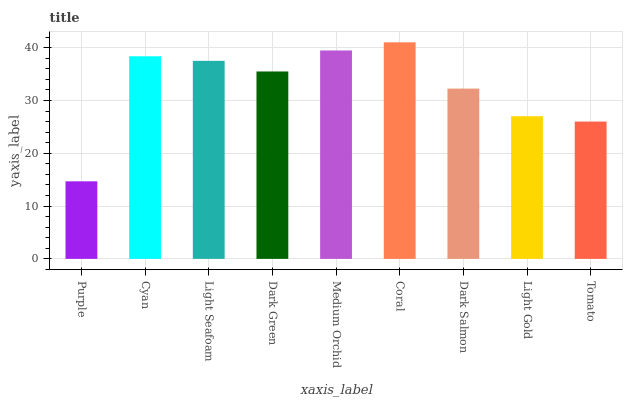Is Purple the minimum?
Answer yes or no. Yes. Is Coral the maximum?
Answer yes or no. Yes. Is Cyan the minimum?
Answer yes or no. No. Is Cyan the maximum?
Answer yes or no. No. Is Cyan greater than Purple?
Answer yes or no. Yes. Is Purple less than Cyan?
Answer yes or no. Yes. Is Purple greater than Cyan?
Answer yes or no. No. Is Cyan less than Purple?
Answer yes or no. No. Is Dark Green the high median?
Answer yes or no. Yes. Is Dark Green the low median?
Answer yes or no. Yes. Is Cyan the high median?
Answer yes or no. No. Is Light Seafoam the low median?
Answer yes or no. No. 